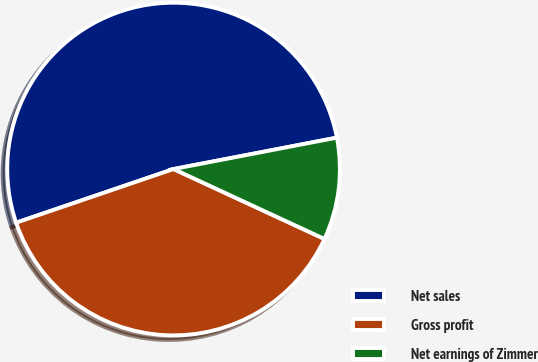<chart> <loc_0><loc_0><loc_500><loc_500><pie_chart><fcel>Net sales<fcel>Gross profit<fcel>Net earnings of Zimmer<nl><fcel>52.21%<fcel>37.87%<fcel>9.93%<nl></chart> 